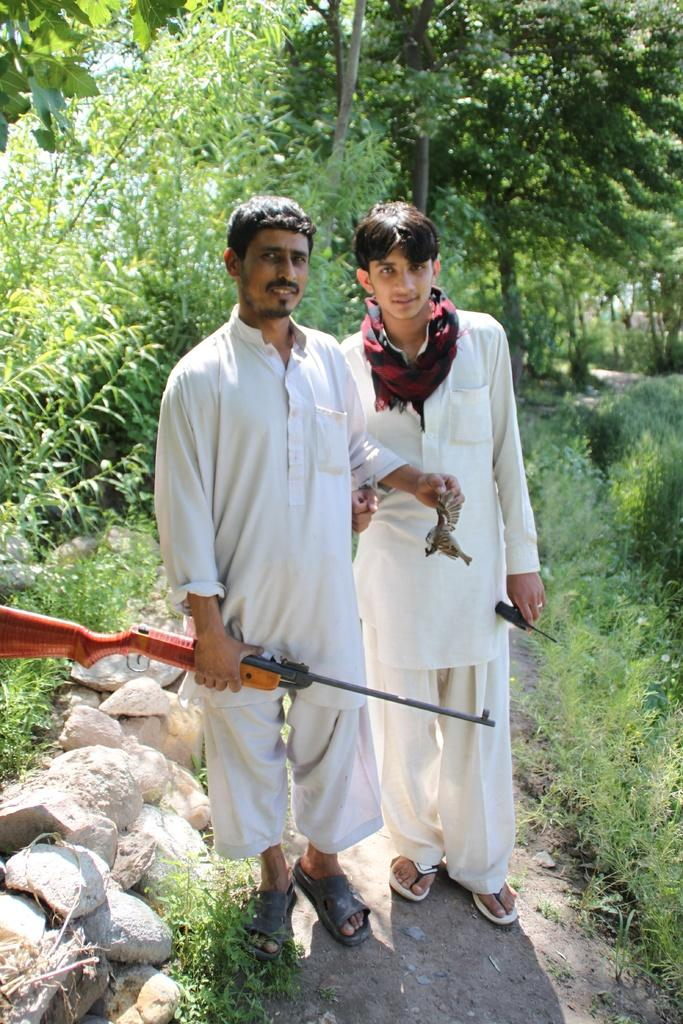How many people are in the image? There are two persons standing in the image. What are the persons holding in the image? The persons are holding objects. What type of natural elements can be seen in the image? There are stones, grass, plants, trees, and the sky visible in the image. Can you tell me how many arches are visible in the image? There are no arches present in the image. Are the persons swimming in the image? There is no indication of swimming in the image; the persons are standing. 